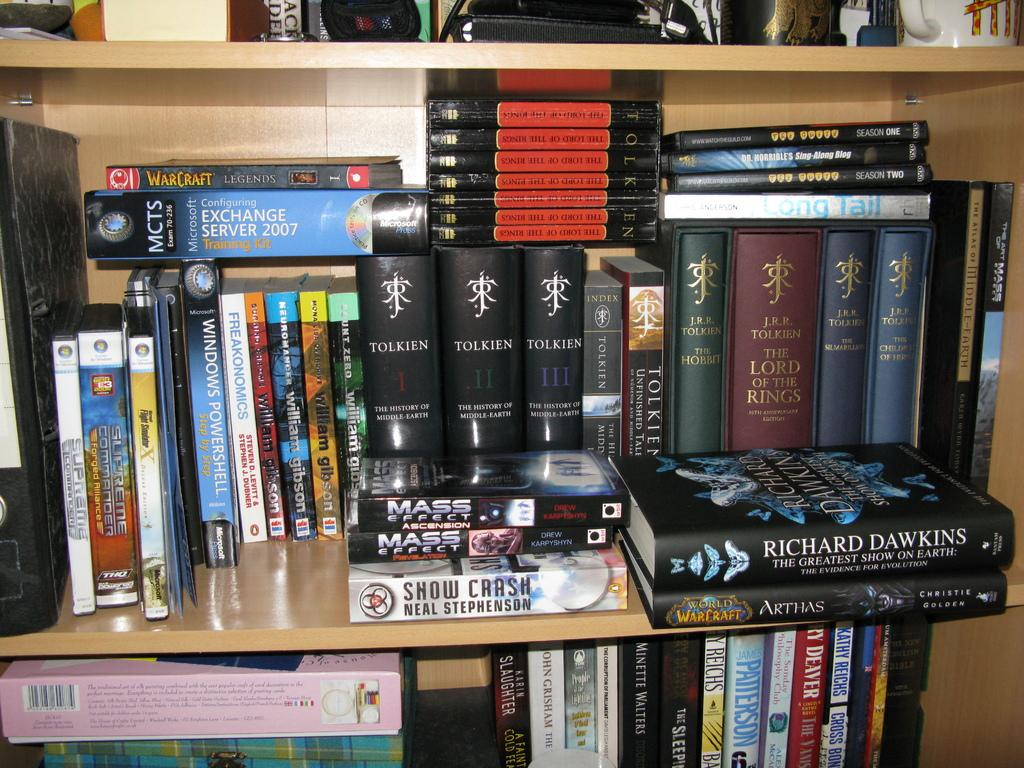What type of items can be seen in the image? There are books and a cardboard box in the image. Where are the books and cardboard box located? They are on wooden shelves in the image. What else might be present on the wooden shelves? There are objects on the wooden shelves, but their specific nature is not mentioned in the facts. How many pies are on the shelves in the image? There is no mention of pies in the image, so we cannot determine their presence or quantity. 